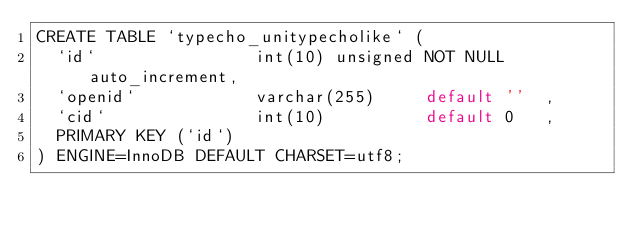Convert code to text. <code><loc_0><loc_0><loc_500><loc_500><_SQL_>CREATE TABLE `typecho_unitypecholike` (
  `id`                int(10) unsigned NOT NULL auto_increment,
  `openid`            varchar(255)     default ''  ,
  `cid`               int(10)          default 0   ,
  PRIMARY KEY (`id`)
) ENGINE=InnoDB DEFAULT CHARSET=utf8;</code> 